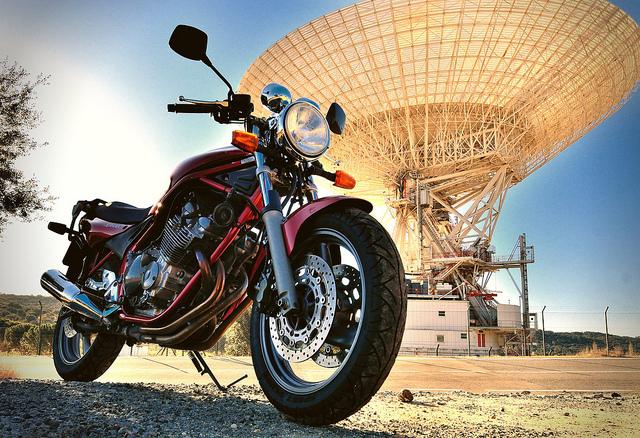Is anyone riding the motorcycle?
Concise answer only. No. What brand of motorcycle is this?
Give a very brief answer. Harley. What is the large object in the background?
Keep it brief. Satellite. 